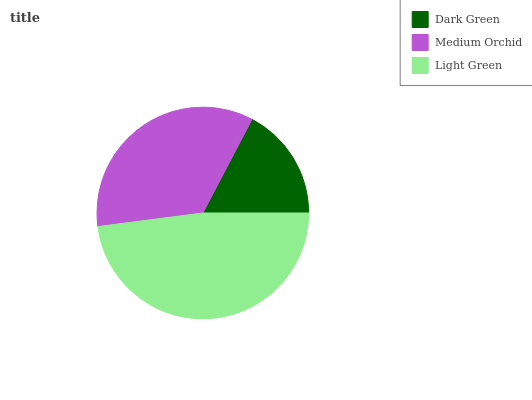Is Dark Green the minimum?
Answer yes or no. Yes. Is Light Green the maximum?
Answer yes or no. Yes. Is Medium Orchid the minimum?
Answer yes or no. No. Is Medium Orchid the maximum?
Answer yes or no. No. Is Medium Orchid greater than Dark Green?
Answer yes or no. Yes. Is Dark Green less than Medium Orchid?
Answer yes or no. Yes. Is Dark Green greater than Medium Orchid?
Answer yes or no. No. Is Medium Orchid less than Dark Green?
Answer yes or no. No. Is Medium Orchid the high median?
Answer yes or no. Yes. Is Medium Orchid the low median?
Answer yes or no. Yes. Is Dark Green the high median?
Answer yes or no. No. Is Light Green the low median?
Answer yes or no. No. 